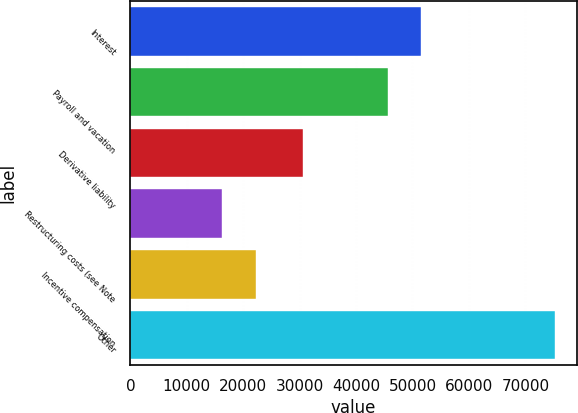Convert chart to OTSL. <chart><loc_0><loc_0><loc_500><loc_500><bar_chart><fcel>Interest<fcel>Payroll and vacation<fcel>Derivative liability<fcel>Restructuring costs (see Note<fcel>Incentive compensation<fcel>Other<nl><fcel>51552.9<fcel>45652<fcel>30633<fcel>16322<fcel>22222.9<fcel>75331<nl></chart> 